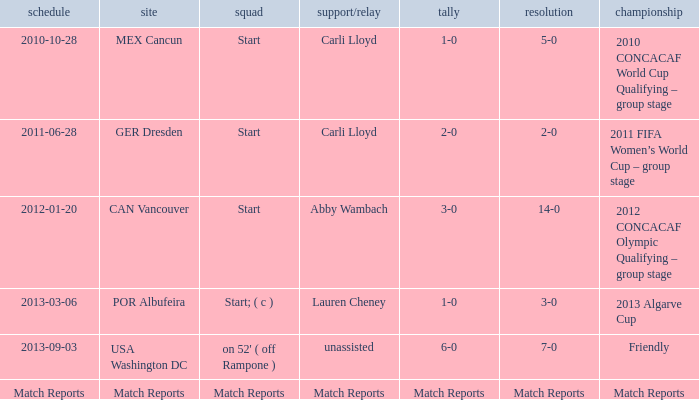Which Assist/pass has a Score of 1-0,a Competition of 2010 concacaf world cup qualifying – group stage? Carli Lloyd. 